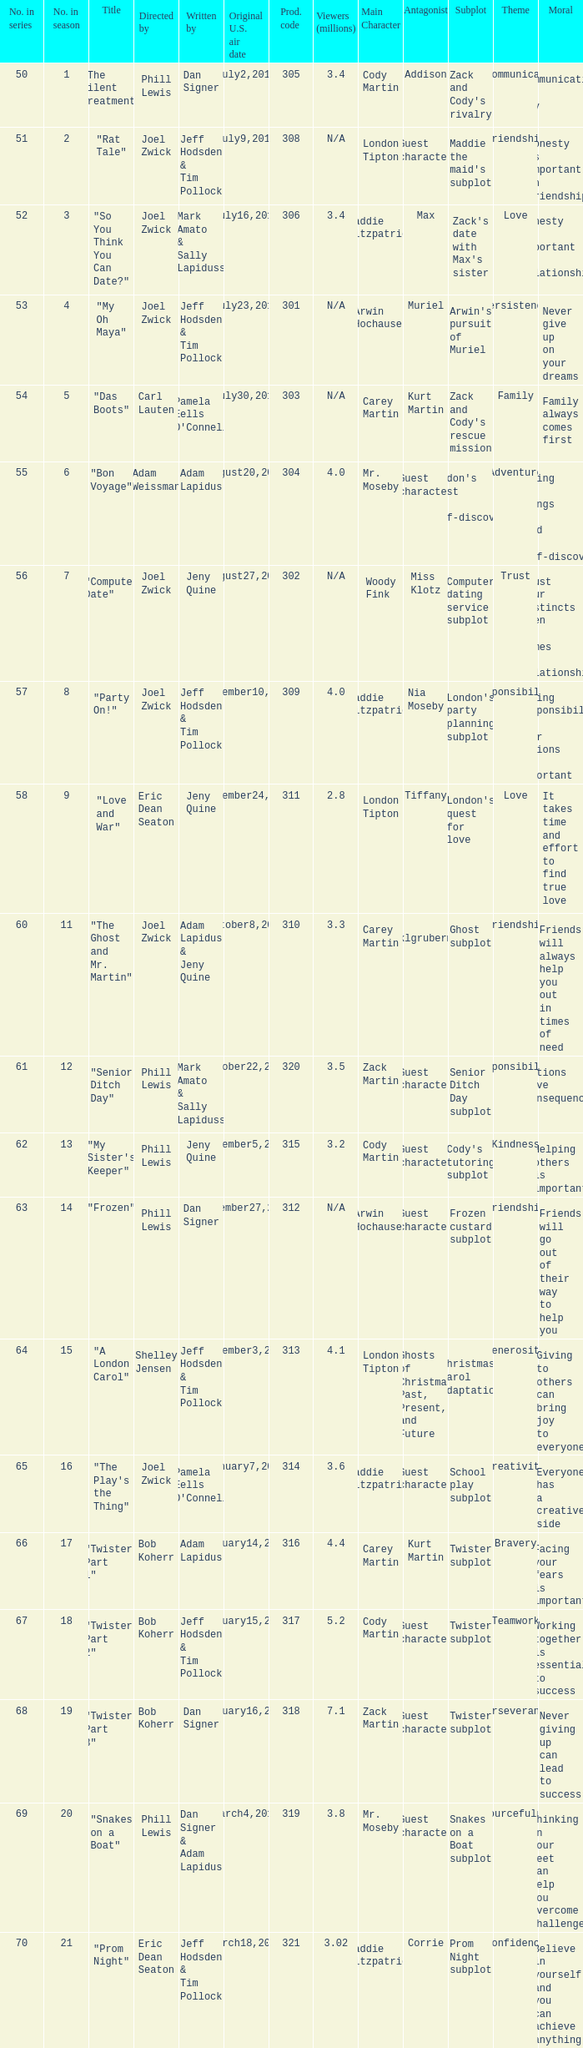How many million viewers watched episode 6? 4.0. Can you give me this table as a dict? {'header': ['No. in series', 'No. in season', 'Title', 'Directed by', 'Written by', 'Original U.S. air date', 'Prod. code', 'Viewers (millions)', 'Main Character', 'Antagonist', 'Subplot', 'Theme', 'Moral'], 'rows': [['50', '1', '"The Silent Treatment"', 'Phill Lewis', 'Dan Signer', 'July2,2010', '305', '3.4', 'Cody Martin', 'Addison', "Zack and Cody's rivalry", 'Miscommunication', 'Communication is key'], ['51', '2', '"Rat Tale"', 'Joel Zwick', 'Jeff Hodsden & Tim Pollock', 'July9,2010', '308', 'N/A', 'London Tipton', 'Guest character', "Maddie the maid's subplot", 'Friendship', 'Honesty is important in friendships'], ['52', '3', '"So You Think You Can Date?"', 'Joel Zwick', 'Mark Amato & Sally Lapiduss', 'July16,2010', '306', '3.4', 'Maddie Fitzpatrick', 'Max', "Zack's date with Max's sister", 'Love', 'Honesty is important in relationships'], ['53', '4', '"My Oh Maya"', 'Joel Zwick', 'Jeff Hodsden & Tim Pollock', 'July23,2010', '301', 'N/A', 'Arwin Hochauser', 'Muriel', "Arwin's pursuit of Muriel", 'Persistence', 'Never give up on your dreams'], ['54', '5', '"Das Boots"', 'Carl Lauten', "Pamela Eells O'Connell", 'July30,2010', '303', 'N/A', 'Carey Martin', 'Kurt Martin', "Zack and Cody's rescue mission", 'Family', 'Family always comes first'], ['55', '6', '"Bon Voyage"', 'Adam Weissman', 'Adam Lapidus', 'August20,2010', '304', '4.0', 'Mr. Moseby', 'Guest character', "London's quest for self-discovery", 'Adventure', 'Trying new things can lead to self-discovery'], ['56', '7', '"Computer Date"', 'Joel Zwick', 'Jeny Quine', 'August27,2010', '302', 'N/A', 'Woody Fink', 'Miss Klotz', 'Computer dating service subplot', 'Trust', 'Trust your instincts when it comes to relationships'], ['57', '8', '"Party On!"', 'Joel Zwick', 'Jeff Hodsden & Tim Pollock', 'September10,2010', '309', '4.0', 'Maddie Fitzpatrick', 'Nia Moseby', "London's party planning subplot", 'Responsibility', 'Taking responsibility for your actions is important'], ['58', '9', '"Love and War"', 'Eric Dean Seaton', 'Jeny Quine', 'September24,2010', '311', '2.8', 'London Tipton', 'Tiffany', "London's quest for love", 'Love', 'It takes time and effort to find true love'], ['60', '11', '"The Ghost and Mr. Martin"', 'Joel Zwick', 'Adam Lapidus & Jeny Quine', 'October8,2010', '310', '3.3', 'Carey Martin', 'Ilsa Schicklgrubermeiger', 'Ghost subplot', 'Friendship', 'Friends will always help you out in times of need'], ['61', '12', '"Senior Ditch Day"', 'Phill Lewis', 'Mark Amato & Sally Lapiduss', 'October22,2010', '320', '3.5', 'Zack Martin', 'Guest character', 'Senior Ditch Day subplot', 'Responsibility', 'Actions have consequences'], ['62', '13', '"My Sister\'s Keeper"', 'Phill Lewis', 'Jeny Quine', 'November5,2010', '315', '3.2', 'Cody Martin', 'Guest character', "Cody's tutoring subplot", 'Kindness', 'Helping others is important'], ['63', '14', '"Frozen"', 'Phill Lewis', 'Dan Signer', 'November27,2010', '312', 'N/A', 'Arwin Hochauser', 'Guest character', 'Frozen custard subplot', 'Friendship', 'Friends will go out of their way to help you'], ['64', '15', '"A London Carol"', 'Shelley Jensen', 'Jeff Hodsden & Tim Pollock', 'December3,2010', '313', '4.1', 'London Tipton', 'Ghosts of Christmas Past, Present, and Future', 'A Christmas Carol adaptation', 'Generosity', 'Giving to others can bring joy to everyone'], ['65', '16', '"The Play\'s the Thing"', 'Joel Zwick', "Pamela Eells O'Connell", 'January7,2011', '314', '3.6', 'Maddie Fitzpatrick', 'Guest character', 'School play subplot', 'Creativity', 'Everyone has a creative side'], ['66', '17', '"Twister: Part 1"', 'Bob Koherr', 'Adam Lapidus', 'January14,2011', '316', '4.4', 'Carey Martin', 'Kurt Martin', 'Twister subplot', 'Bravery', 'Facing your fears is important'], ['67', '18', '"Twister: Part 2"', 'Bob Koherr', 'Jeff Hodsden & Tim Pollock', 'January15,2011', '317', '5.2', 'Cody Martin', 'Guest character', 'Twister subplot', 'Teamwork', 'Working together is essential to success'], ['68', '19', '"Twister: Part 3"', 'Bob Koherr', 'Dan Signer', 'January16,2011', '318', '7.1', 'Zack Martin', 'Guest character', 'Twister subplot', 'Perseverance', 'Never giving up can lead to success'], ['69', '20', '"Snakes on a Boat"', 'Phill Lewis', 'Dan Signer & Adam Lapidus', 'March4,2011', '319', '3.8', 'Mr. Moseby', 'Guest character', 'Snakes on a Boat subplot', 'Resourcefulness', 'Thinking on your feet can help you overcome challenges'], ['70', '21', '"Prom Night"', 'Eric Dean Seaton', 'Jeff Hodsden & Tim Pollock', 'March18,2011', '321', '3.02', 'Maddie Fitzpatrick', 'Corrie', 'Prom Night subplot', 'Confidence', 'Believe in yourself and you can achieve anything.']]} 